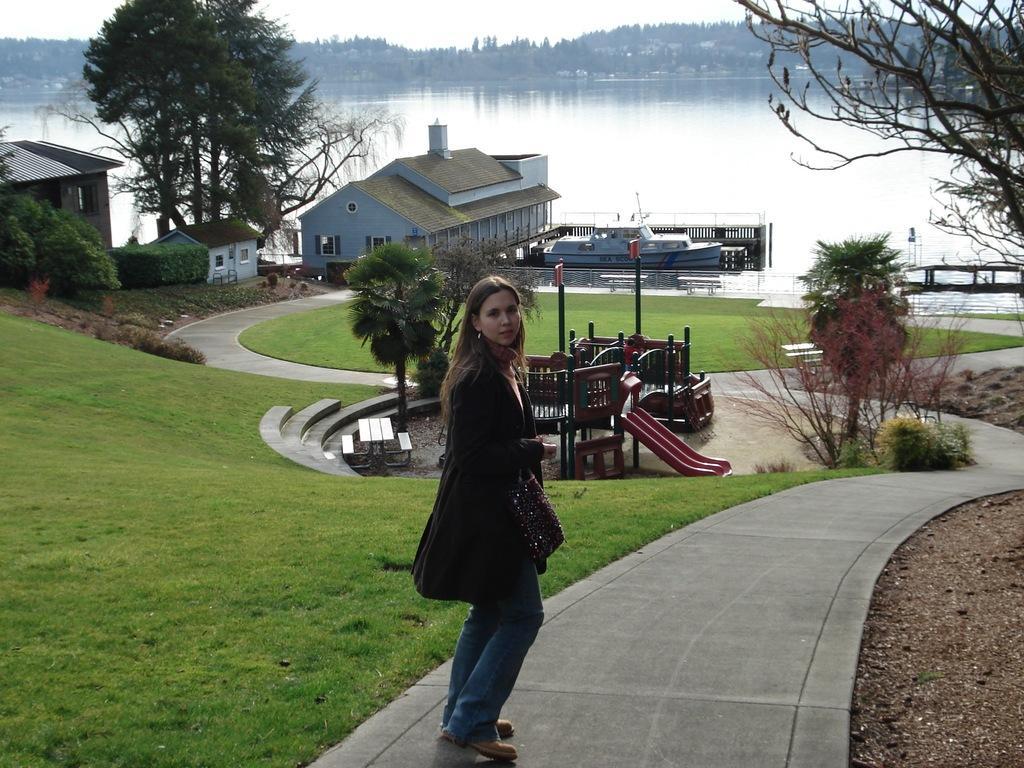How would you summarize this image in a sentence or two? In this picture there is a girl wearing a black color sweater is standing on the walking area and giving a pose. Behind there is a playing ground in the garden. Behind there is a blue color shade house and boat parked beside it. In the background we can see a river and some tree. 